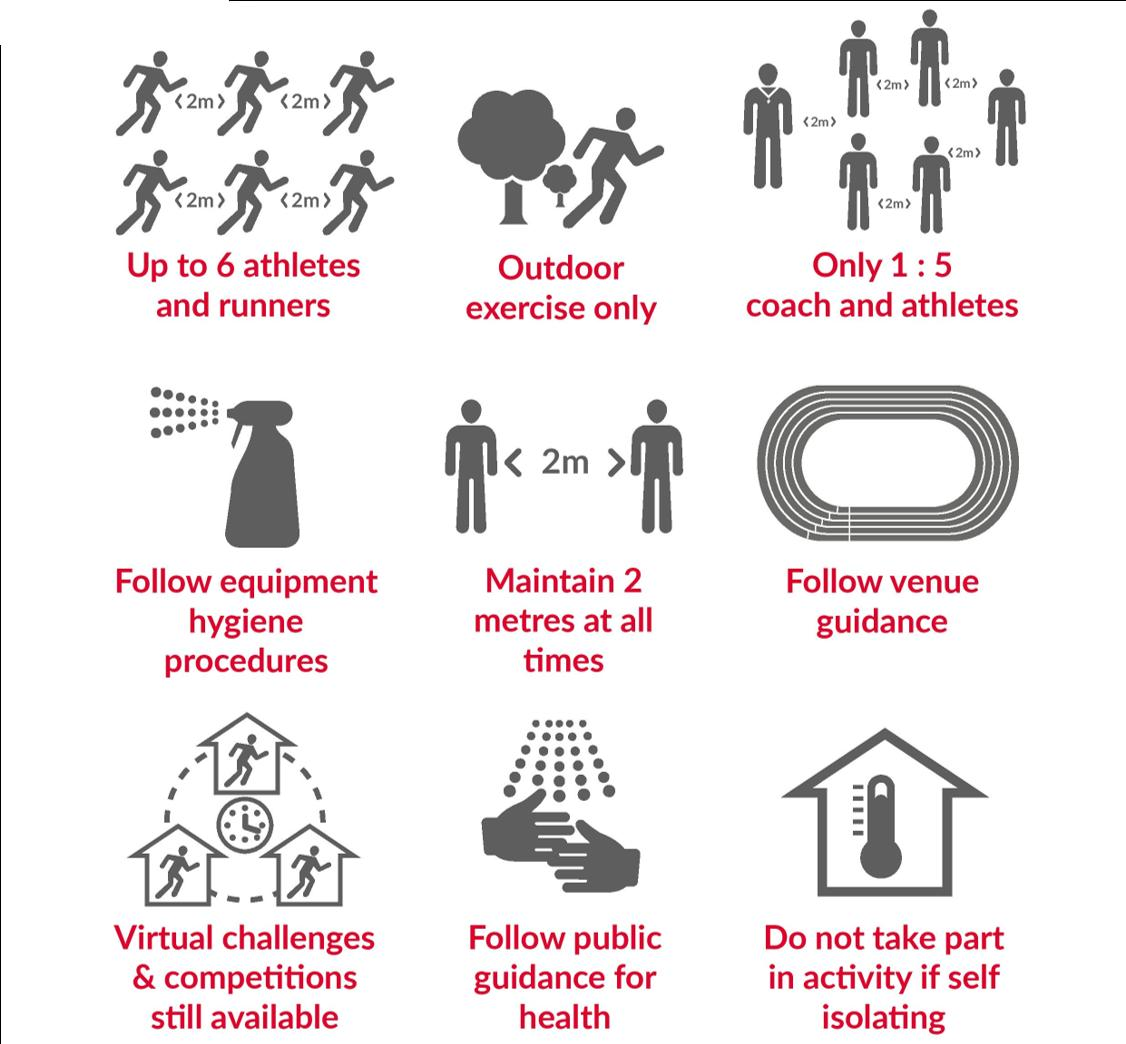Mention a couple of crucial points in this snapshot. It is permissible for a coach to have a maximum of five athletes under their supervision. A minimum distance of 2 meters should be maintained between all participants at all times. It is only permissible to engage in exercises that are performed outdoors. In situations where self-isolation is advisable, one should refrain from participating in any activities. Virtual challenges and competitions are still available. 